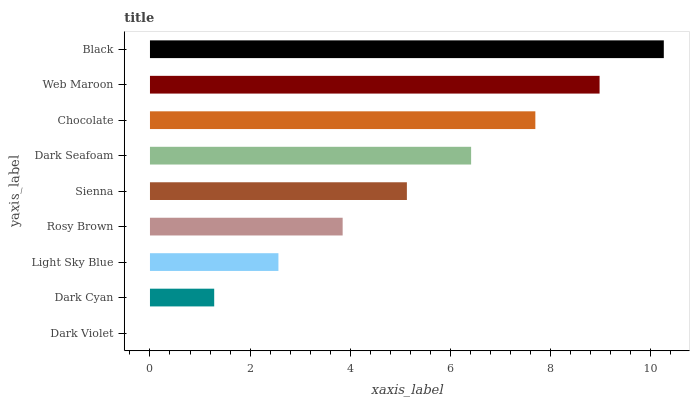Is Dark Violet the minimum?
Answer yes or no. Yes. Is Black the maximum?
Answer yes or no. Yes. Is Dark Cyan the minimum?
Answer yes or no. No. Is Dark Cyan the maximum?
Answer yes or no. No. Is Dark Cyan greater than Dark Violet?
Answer yes or no. Yes. Is Dark Violet less than Dark Cyan?
Answer yes or no. Yes. Is Dark Violet greater than Dark Cyan?
Answer yes or no. No. Is Dark Cyan less than Dark Violet?
Answer yes or no. No. Is Sienna the high median?
Answer yes or no. Yes. Is Sienna the low median?
Answer yes or no. Yes. Is Dark Violet the high median?
Answer yes or no. No. Is Dark Cyan the low median?
Answer yes or no. No. 